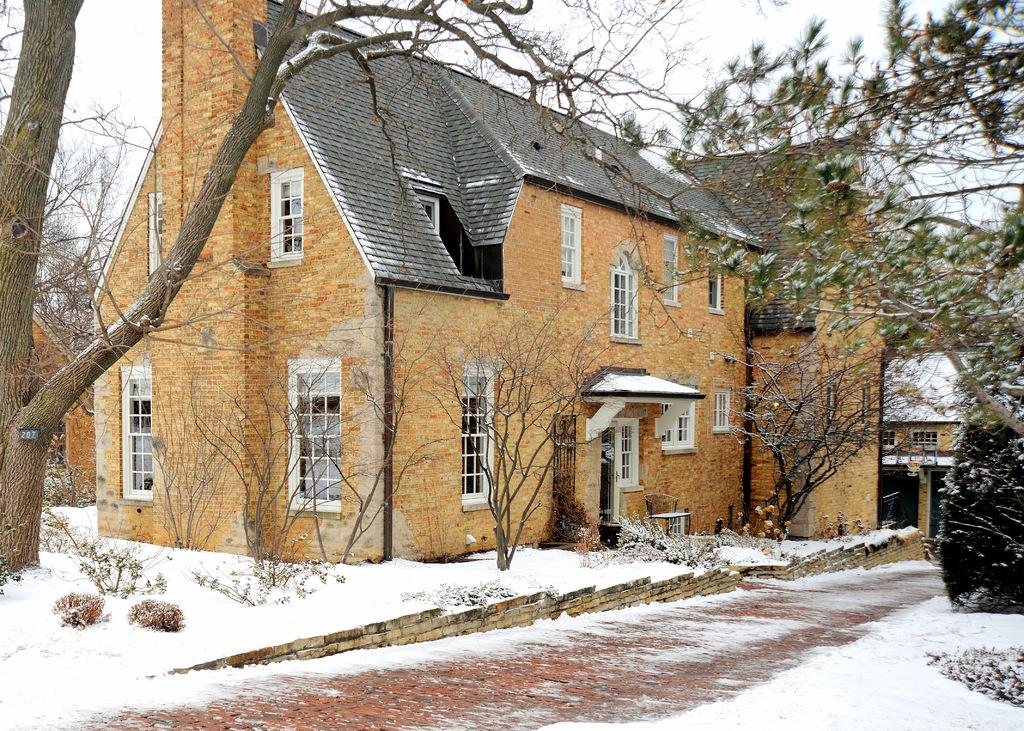What type of structures can be seen in the image? There are buildings in the image. What is located in front of the buildings? There are trees in front of the buildings. What is the weather like in the image? There is snow visible in the image, indicating a cold or wintry weather. What is visible above the buildings? The sky is visible in the image. What date is marked on the calendar in the image? There is no calendar present in the image. What advice does the father give to his child in the image? There is no father or child present in the image. 